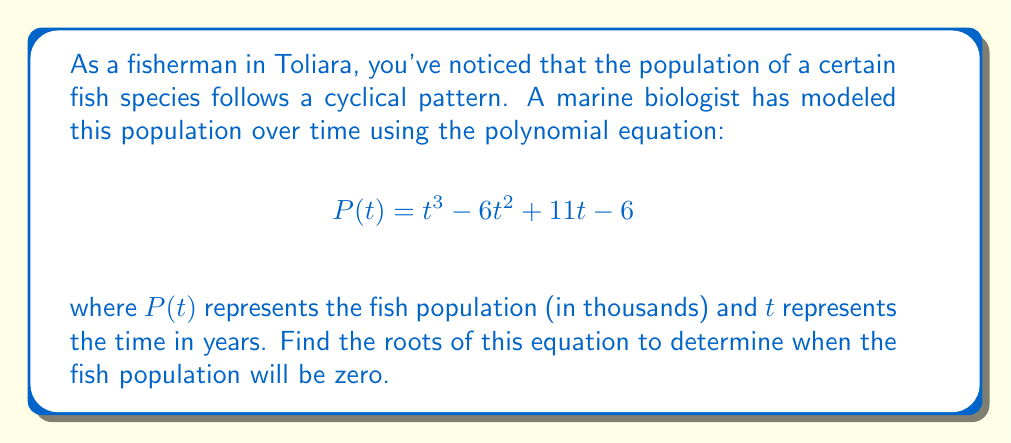What is the answer to this math problem? To find the roots of the polynomial equation, we need to solve:

$$t^3 - 6t^2 + 11t - 6 = 0$$

Let's approach this step-by-step:

1) First, we can try to factor out a common factor if possible. In this case, there's no common factor.

2) Next, we can try to guess one root. By inspection or trial and error, we can find that $t = 1$ is a root.

3) Since $t = 1$ is a root, $(t - 1)$ is a factor of the polynomial. We can use polynomial long division to find the other factor:

   $$\frac{t^3 - 6t^2 + 11t - 6}{t - 1} = t^2 - 5t + 6$$

4) So our polynomial can be factored as:

   $$(t - 1)(t^2 - 5t + 6) = 0$$

5) We've already found one root: $t = 1$. For the quadratic factor, we can use the quadratic formula:

   $$t = \frac{-b \pm \sqrt{b^2 - 4ac}}{2a}$$

   where $a = 1$, $b = -5$, and $c = 6$

6) Substituting these values:

   $$t = \frac{5 \pm \sqrt{25 - 24}}{2} = \frac{5 \pm 1}{2}$$

7) This gives us two more roots:

   $$t = \frac{5 + 1}{2} = 3$$ and $$t = \frac{5 - 1}{2} = 2$$

Therefore, the roots of the equation are $t = 1$, $t = 2$, and $t = 3$.
Answer: $t = 1$, $t = 2$, $t = 3$ 